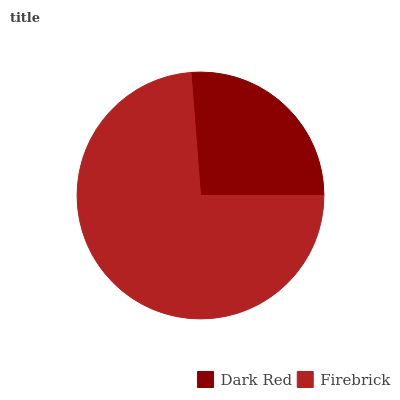Is Dark Red the minimum?
Answer yes or no. Yes. Is Firebrick the maximum?
Answer yes or no. Yes. Is Firebrick the minimum?
Answer yes or no. No. Is Firebrick greater than Dark Red?
Answer yes or no. Yes. Is Dark Red less than Firebrick?
Answer yes or no. Yes. Is Dark Red greater than Firebrick?
Answer yes or no. No. Is Firebrick less than Dark Red?
Answer yes or no. No. Is Firebrick the high median?
Answer yes or no. Yes. Is Dark Red the low median?
Answer yes or no. Yes. Is Dark Red the high median?
Answer yes or no. No. Is Firebrick the low median?
Answer yes or no. No. 